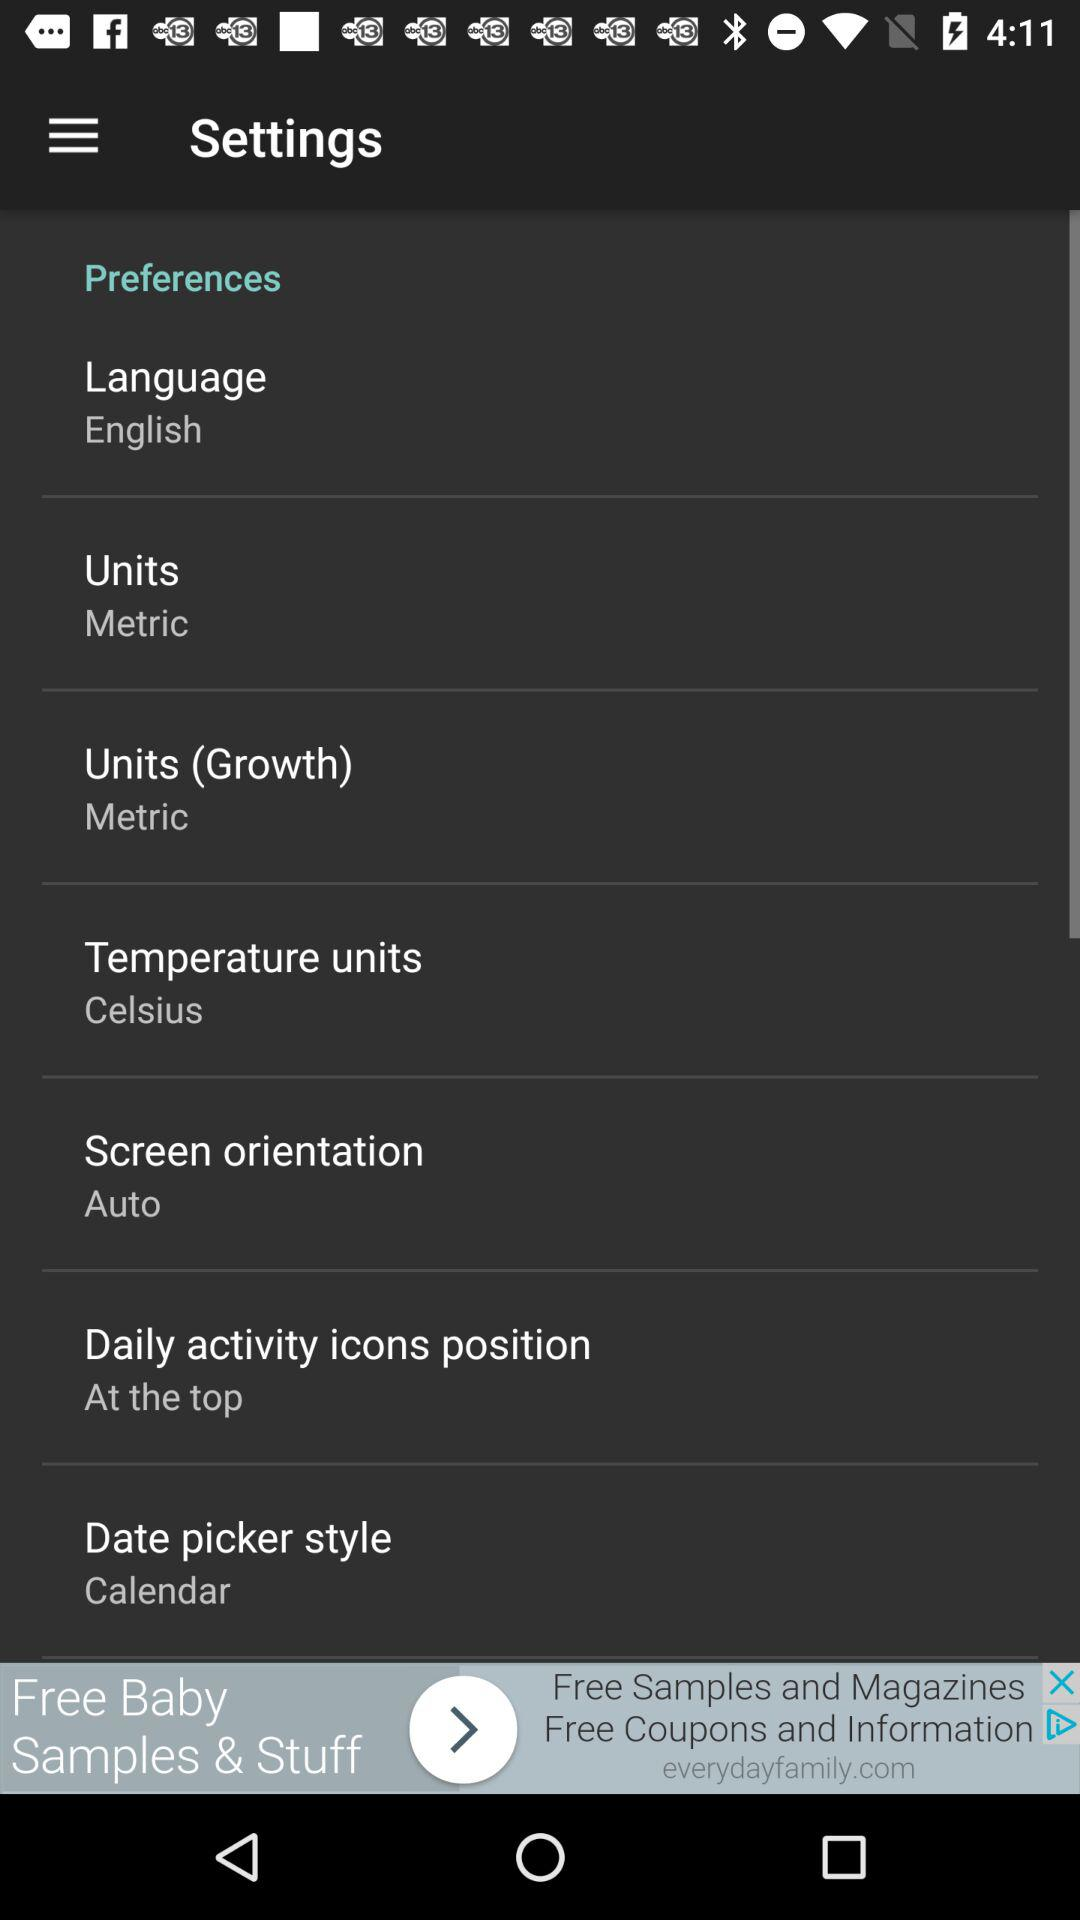Which units have been chosen? The unit chosen is "Metric". 